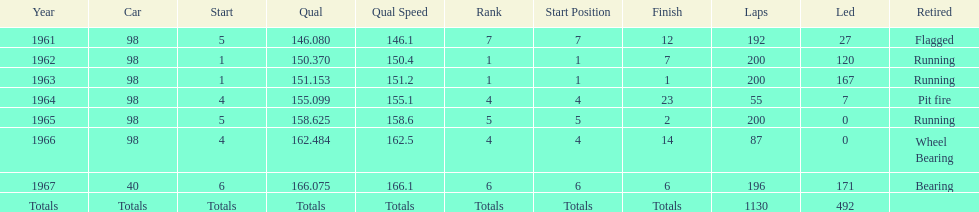What car ranked #1 from 1962-1963? 98. 